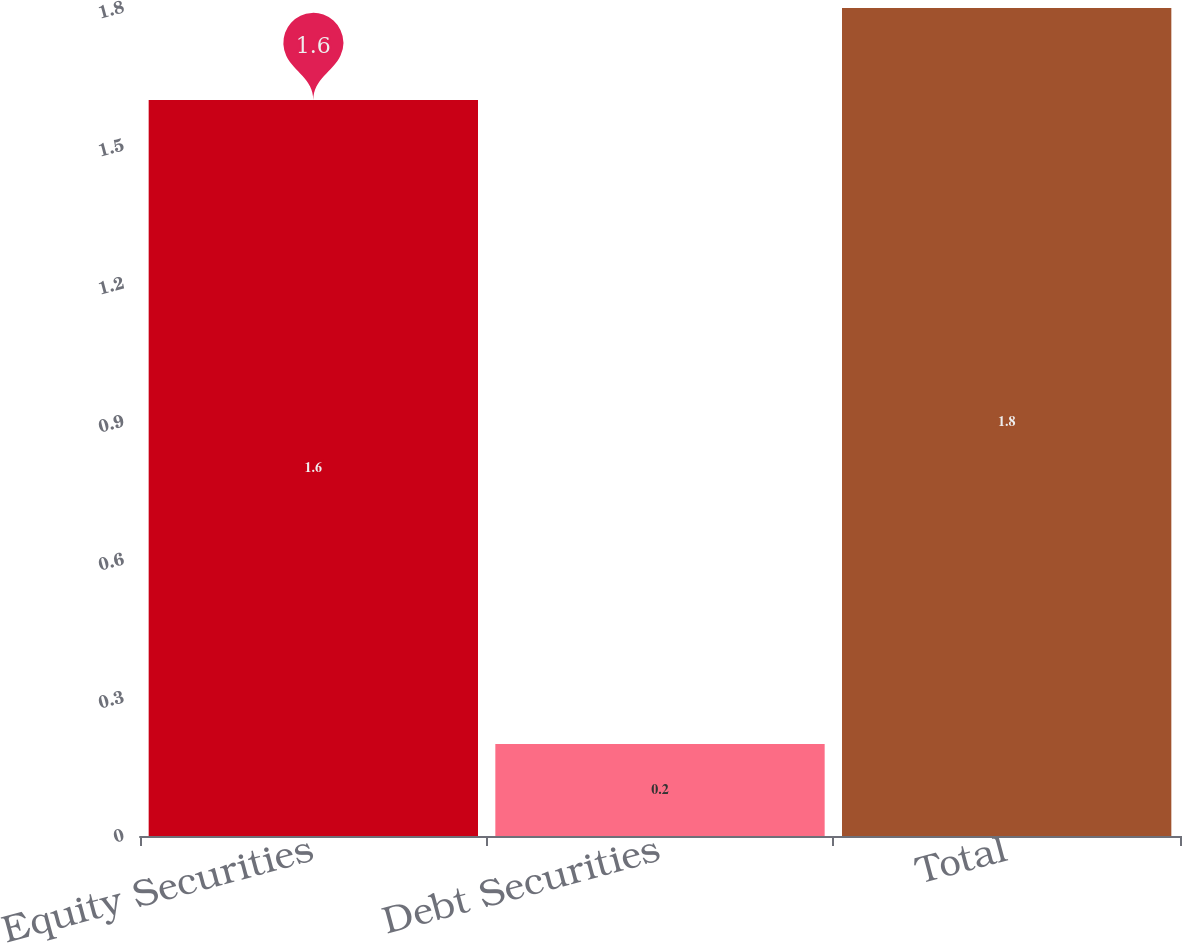Convert chart to OTSL. <chart><loc_0><loc_0><loc_500><loc_500><bar_chart><fcel>Equity Securities<fcel>Debt Securities<fcel>Total<nl><fcel>1.6<fcel>0.2<fcel>1.8<nl></chart> 